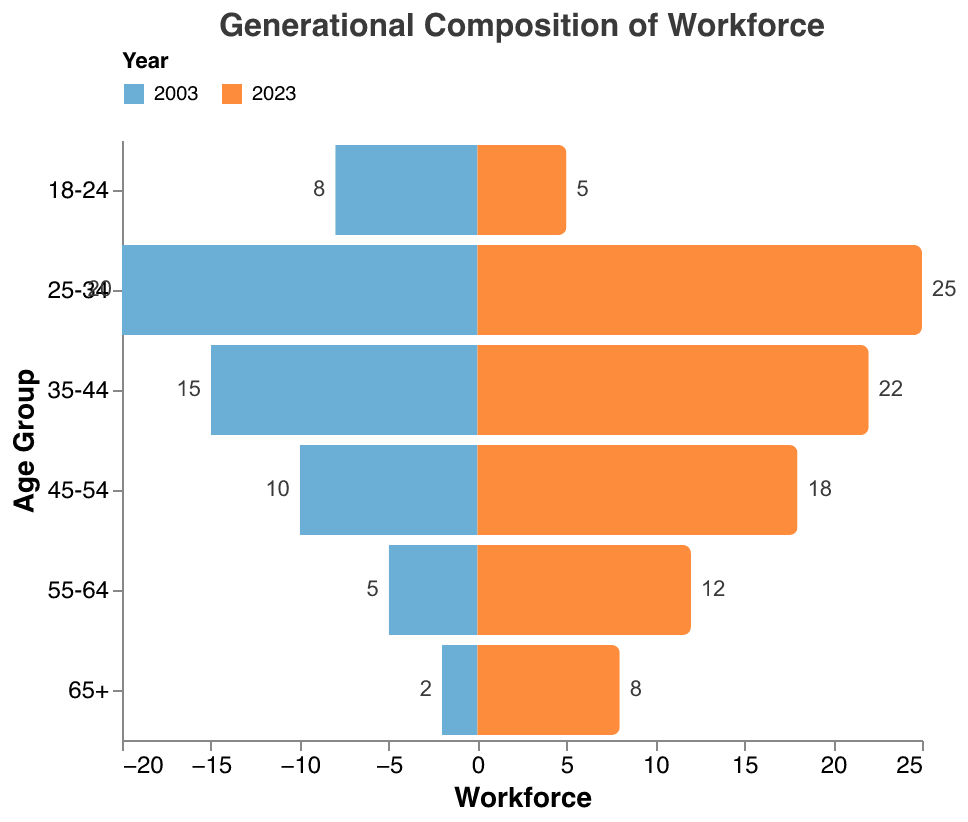what is the title of this figure? The title of the figure is given at the top of the plot. It reads "Generational Composition of Workforce".
Answer: Generational Composition of Workforce How many age groups are represented in the data for both 2003 and 2023? The age groups can be counted from the Y-axis of the figure. There are six distinct age groups represented.
Answer: 6 Which age group had the largest workforce in 2023? To find the largest workforce, look for the bar with the largest positive value for the year 2023 on the X-axis. The age group 25-34 has the largest workforce in 2023.
Answer: 25-34 What is the overall trend in workforce composition for the age group 65+ from 2003 to 2023? Compare the bar lengths for the age group 65+ across 2003 and 2023. The workforce for this age group has increased from 2 in 2003 to 8 in 2023.
Answer: Increased What is the percentage increase in workforce for the age group 55-64 from 2003 to 2023? First, calculate the difference between the workforce values for 2023 and 2003 for the age group 55-64. The difference is 12 - 5 = 7. Then, calculate the percentage increase as (7 / 5) * 100% = 140%.
Answer: 140% Which age group saw a decrease in workforce from 2003 to 2023? Identify bars that are shorter for 2023 compared to 2003. The age group 18-24 shows a decrease, from 8 in 2003 to 5 in 2023.
Answer: 18-24 What is the total workforce in 2003? Add up the workforce values for all age groups in 2003: 2 + 5 + 10 + 15 + 20 + 8 = 60.
Answer: 60 What is the average workforce across all age groups in 2023? Add up the workforce values for all age groups in 2023: 8 + 12 + 18 + 22 + 25 + 5 = 90. Then divide by the number of age groups, which is 6. The average is 90 / 6 = 15.
Answer: 15 Compare the workforce for the age groups 25-34 and 45-54 in 2023. Which is larger, and by how much? The workforce for the age group 25-34 in 2023 is 25, and for the age group 45-54 is 18. The difference is 25 - 18 = 7. So, 25-34 is larger by 7.
Answer: 25-34 is larger by 7 How does the total workforce change from 2003 to 2023? Calculate the total workforce for both years. For 2003: 2 + 5 + 10 + 15 + 20 + 8 = 60. For 2023: 8 + 12 + 18 + 22 + 25 + 5 = 90. The total workforce increased by 90 - 60 = 30.
Answer: Increased by 30 